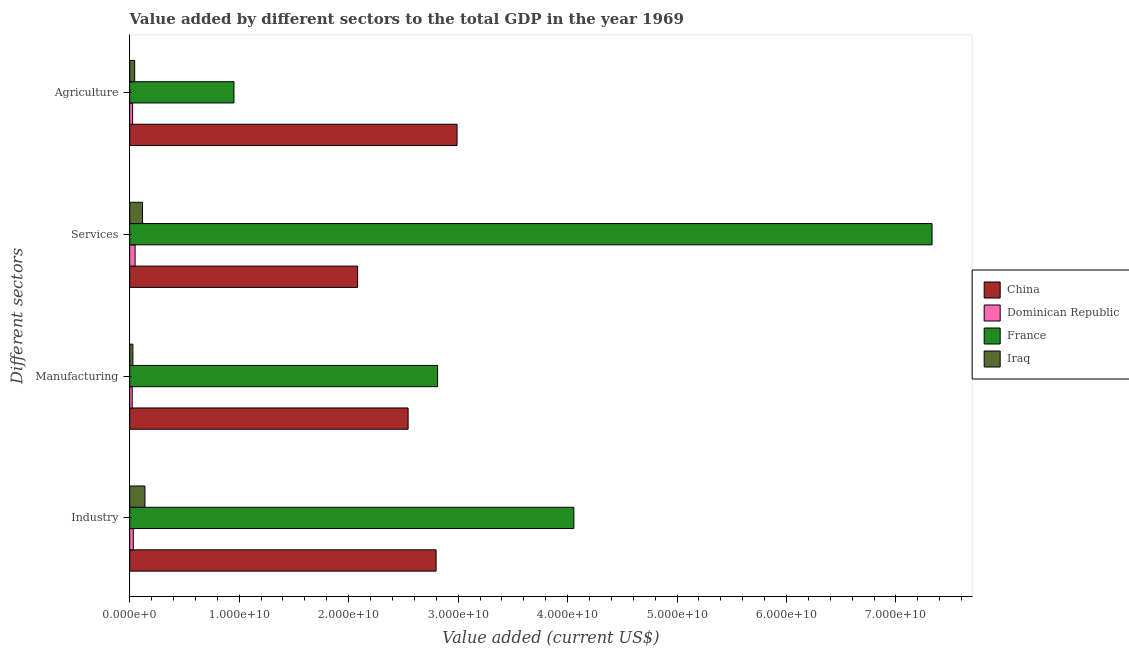How many groups of bars are there?
Offer a terse response. 4. Are the number of bars per tick equal to the number of legend labels?
Offer a terse response. Yes. How many bars are there on the 2nd tick from the top?
Your response must be concise. 4. How many bars are there on the 1st tick from the bottom?
Ensure brevity in your answer.  4. What is the label of the 4th group of bars from the top?
Offer a terse response. Industry. What is the value added by manufacturing sector in Dominican Republic?
Provide a short and direct response. 2.30e+08. Across all countries, what is the maximum value added by services sector?
Provide a short and direct response. 7.33e+1. Across all countries, what is the minimum value added by agricultural sector?
Offer a terse response. 2.62e+08. In which country was the value added by industrial sector minimum?
Your answer should be very brief. Dominican Republic. What is the total value added by agricultural sector in the graph?
Offer a very short reply. 4.01e+1. What is the difference between the value added by manufacturing sector in France and that in Iraq?
Provide a succinct answer. 2.78e+1. What is the difference between the value added by agricultural sector in China and the value added by manufacturing sector in Dominican Republic?
Your response must be concise. 2.97e+1. What is the average value added by agricultural sector per country?
Make the answer very short. 1.00e+1. What is the difference between the value added by manufacturing sector and value added by agricultural sector in Dominican Republic?
Your answer should be very brief. -3.24e+07. What is the ratio of the value added by manufacturing sector in Dominican Republic to that in France?
Ensure brevity in your answer.  0.01. Is the value added by industrial sector in Iraq less than that in France?
Give a very brief answer. Yes. What is the difference between the highest and the second highest value added by services sector?
Provide a short and direct response. 5.25e+1. What is the difference between the highest and the lowest value added by agricultural sector?
Offer a terse response. 2.96e+1. In how many countries, is the value added by services sector greater than the average value added by services sector taken over all countries?
Offer a very short reply. 1. Is the sum of the value added by services sector in Dominican Republic and France greater than the maximum value added by industrial sector across all countries?
Provide a short and direct response. Yes. How many countries are there in the graph?
Your answer should be very brief. 4. How many legend labels are there?
Your response must be concise. 4. What is the title of the graph?
Give a very brief answer. Value added by different sectors to the total GDP in the year 1969. Does "Andorra" appear as one of the legend labels in the graph?
Your response must be concise. No. What is the label or title of the X-axis?
Provide a succinct answer. Value added (current US$). What is the label or title of the Y-axis?
Your answer should be compact. Different sectors. What is the Value added (current US$) in China in Industry?
Give a very brief answer. 2.80e+1. What is the Value added (current US$) of Dominican Republic in Industry?
Keep it short and to the point. 3.27e+08. What is the Value added (current US$) of France in Industry?
Make the answer very short. 4.06e+1. What is the Value added (current US$) in Iraq in Industry?
Your answer should be compact. 1.39e+09. What is the Value added (current US$) of China in Manufacturing?
Provide a succinct answer. 2.54e+1. What is the Value added (current US$) of Dominican Republic in Manufacturing?
Your answer should be very brief. 2.30e+08. What is the Value added (current US$) in France in Manufacturing?
Make the answer very short. 2.81e+1. What is the Value added (current US$) of Iraq in Manufacturing?
Provide a short and direct response. 2.88e+08. What is the Value added (current US$) of China in Services?
Give a very brief answer. 2.08e+1. What is the Value added (current US$) in Dominican Republic in Services?
Your answer should be very brief. 4.90e+08. What is the Value added (current US$) of France in Services?
Offer a terse response. 7.33e+1. What is the Value added (current US$) of Iraq in Services?
Make the answer very short. 1.17e+09. What is the Value added (current US$) of China in Agriculture?
Provide a succinct answer. 2.99e+1. What is the Value added (current US$) in Dominican Republic in Agriculture?
Your response must be concise. 2.62e+08. What is the Value added (current US$) in France in Agriculture?
Your answer should be compact. 9.52e+09. What is the Value added (current US$) of Iraq in Agriculture?
Your answer should be very brief. 4.52e+08. Across all Different sectors, what is the maximum Value added (current US$) in China?
Your response must be concise. 2.99e+1. Across all Different sectors, what is the maximum Value added (current US$) of Dominican Republic?
Your response must be concise. 4.90e+08. Across all Different sectors, what is the maximum Value added (current US$) of France?
Keep it short and to the point. 7.33e+1. Across all Different sectors, what is the maximum Value added (current US$) in Iraq?
Offer a very short reply. 1.39e+09. Across all Different sectors, what is the minimum Value added (current US$) in China?
Your response must be concise. 2.08e+1. Across all Different sectors, what is the minimum Value added (current US$) of Dominican Republic?
Your response must be concise. 2.30e+08. Across all Different sectors, what is the minimum Value added (current US$) of France?
Offer a very short reply. 9.52e+09. Across all Different sectors, what is the minimum Value added (current US$) of Iraq?
Provide a short and direct response. 2.88e+08. What is the total Value added (current US$) in China in the graph?
Provide a short and direct response. 1.04e+11. What is the total Value added (current US$) of Dominican Republic in the graph?
Offer a terse response. 1.31e+09. What is the total Value added (current US$) in France in the graph?
Give a very brief answer. 1.52e+11. What is the total Value added (current US$) in Iraq in the graph?
Keep it short and to the point. 3.30e+09. What is the difference between the Value added (current US$) in China in Industry and that in Manufacturing?
Your response must be concise. 2.56e+09. What is the difference between the Value added (current US$) of Dominican Republic in Industry and that in Manufacturing?
Keep it short and to the point. 9.74e+07. What is the difference between the Value added (current US$) of France in Industry and that in Manufacturing?
Keep it short and to the point. 1.24e+1. What is the difference between the Value added (current US$) of Iraq in Industry and that in Manufacturing?
Ensure brevity in your answer.  1.10e+09. What is the difference between the Value added (current US$) of China in Industry and that in Services?
Provide a succinct answer. 7.17e+09. What is the difference between the Value added (current US$) of Dominican Republic in Industry and that in Services?
Your response must be concise. -1.63e+08. What is the difference between the Value added (current US$) of France in Industry and that in Services?
Provide a short and direct response. -3.27e+1. What is the difference between the Value added (current US$) of Iraq in Industry and that in Services?
Provide a short and direct response. 2.20e+08. What is the difference between the Value added (current US$) of China in Industry and that in Agriculture?
Your answer should be compact. -1.91e+09. What is the difference between the Value added (current US$) of Dominican Republic in Industry and that in Agriculture?
Offer a terse response. 6.50e+07. What is the difference between the Value added (current US$) of France in Industry and that in Agriculture?
Give a very brief answer. 3.11e+1. What is the difference between the Value added (current US$) of Iraq in Industry and that in Agriculture?
Your answer should be compact. 9.36e+08. What is the difference between the Value added (current US$) of China in Manufacturing and that in Services?
Your response must be concise. 4.61e+09. What is the difference between the Value added (current US$) in Dominican Republic in Manufacturing and that in Services?
Make the answer very short. -2.61e+08. What is the difference between the Value added (current US$) of France in Manufacturing and that in Services?
Offer a very short reply. -4.52e+1. What is the difference between the Value added (current US$) of Iraq in Manufacturing and that in Services?
Give a very brief answer. -8.80e+08. What is the difference between the Value added (current US$) of China in Manufacturing and that in Agriculture?
Make the answer very short. -4.47e+09. What is the difference between the Value added (current US$) in Dominican Republic in Manufacturing and that in Agriculture?
Your answer should be very brief. -3.24e+07. What is the difference between the Value added (current US$) in France in Manufacturing and that in Agriculture?
Your answer should be very brief. 1.86e+1. What is the difference between the Value added (current US$) of Iraq in Manufacturing and that in Agriculture?
Provide a succinct answer. -1.64e+08. What is the difference between the Value added (current US$) of China in Services and that in Agriculture?
Provide a succinct answer. -9.08e+09. What is the difference between the Value added (current US$) of Dominican Republic in Services and that in Agriculture?
Keep it short and to the point. 2.28e+08. What is the difference between the Value added (current US$) of France in Services and that in Agriculture?
Your answer should be compact. 6.38e+1. What is the difference between the Value added (current US$) of Iraq in Services and that in Agriculture?
Give a very brief answer. 7.16e+08. What is the difference between the Value added (current US$) of China in Industry and the Value added (current US$) of Dominican Republic in Manufacturing?
Offer a very short reply. 2.78e+1. What is the difference between the Value added (current US$) of China in Industry and the Value added (current US$) of France in Manufacturing?
Your response must be concise. -1.35e+08. What is the difference between the Value added (current US$) of China in Industry and the Value added (current US$) of Iraq in Manufacturing?
Your answer should be very brief. 2.77e+1. What is the difference between the Value added (current US$) of Dominican Republic in Industry and the Value added (current US$) of France in Manufacturing?
Keep it short and to the point. -2.78e+1. What is the difference between the Value added (current US$) in Dominican Republic in Industry and the Value added (current US$) in Iraq in Manufacturing?
Ensure brevity in your answer.  3.87e+07. What is the difference between the Value added (current US$) of France in Industry and the Value added (current US$) of Iraq in Manufacturing?
Ensure brevity in your answer.  4.03e+1. What is the difference between the Value added (current US$) of China in Industry and the Value added (current US$) of Dominican Republic in Services?
Provide a short and direct response. 2.75e+1. What is the difference between the Value added (current US$) in China in Industry and the Value added (current US$) in France in Services?
Your response must be concise. -4.53e+1. What is the difference between the Value added (current US$) in China in Industry and the Value added (current US$) in Iraq in Services?
Your response must be concise. 2.68e+1. What is the difference between the Value added (current US$) in Dominican Republic in Industry and the Value added (current US$) in France in Services?
Your response must be concise. -7.30e+1. What is the difference between the Value added (current US$) in Dominican Republic in Industry and the Value added (current US$) in Iraq in Services?
Provide a succinct answer. -8.41e+08. What is the difference between the Value added (current US$) of France in Industry and the Value added (current US$) of Iraq in Services?
Make the answer very short. 3.94e+1. What is the difference between the Value added (current US$) of China in Industry and the Value added (current US$) of Dominican Republic in Agriculture?
Offer a very short reply. 2.77e+1. What is the difference between the Value added (current US$) in China in Industry and the Value added (current US$) in France in Agriculture?
Provide a short and direct response. 1.85e+1. What is the difference between the Value added (current US$) in China in Industry and the Value added (current US$) in Iraq in Agriculture?
Ensure brevity in your answer.  2.75e+1. What is the difference between the Value added (current US$) in Dominican Republic in Industry and the Value added (current US$) in France in Agriculture?
Offer a very short reply. -9.20e+09. What is the difference between the Value added (current US$) in Dominican Republic in Industry and the Value added (current US$) in Iraq in Agriculture?
Offer a very short reply. -1.25e+08. What is the difference between the Value added (current US$) in France in Industry and the Value added (current US$) in Iraq in Agriculture?
Provide a succinct answer. 4.01e+1. What is the difference between the Value added (current US$) in China in Manufacturing and the Value added (current US$) in Dominican Republic in Services?
Your answer should be compact. 2.49e+1. What is the difference between the Value added (current US$) in China in Manufacturing and the Value added (current US$) in France in Services?
Ensure brevity in your answer.  -4.79e+1. What is the difference between the Value added (current US$) in China in Manufacturing and the Value added (current US$) in Iraq in Services?
Your response must be concise. 2.43e+1. What is the difference between the Value added (current US$) of Dominican Republic in Manufacturing and the Value added (current US$) of France in Services?
Ensure brevity in your answer.  -7.31e+1. What is the difference between the Value added (current US$) in Dominican Republic in Manufacturing and the Value added (current US$) in Iraq in Services?
Your answer should be very brief. -9.39e+08. What is the difference between the Value added (current US$) of France in Manufacturing and the Value added (current US$) of Iraq in Services?
Give a very brief answer. 2.70e+1. What is the difference between the Value added (current US$) of China in Manufacturing and the Value added (current US$) of Dominican Republic in Agriculture?
Your answer should be compact. 2.52e+1. What is the difference between the Value added (current US$) in China in Manufacturing and the Value added (current US$) in France in Agriculture?
Keep it short and to the point. 1.59e+1. What is the difference between the Value added (current US$) in China in Manufacturing and the Value added (current US$) in Iraq in Agriculture?
Your answer should be compact. 2.50e+1. What is the difference between the Value added (current US$) of Dominican Republic in Manufacturing and the Value added (current US$) of France in Agriculture?
Your answer should be compact. -9.29e+09. What is the difference between the Value added (current US$) of Dominican Republic in Manufacturing and the Value added (current US$) of Iraq in Agriculture?
Give a very brief answer. -2.22e+08. What is the difference between the Value added (current US$) of France in Manufacturing and the Value added (current US$) of Iraq in Agriculture?
Provide a succinct answer. 2.77e+1. What is the difference between the Value added (current US$) of China in Services and the Value added (current US$) of Dominican Republic in Agriculture?
Provide a short and direct response. 2.06e+1. What is the difference between the Value added (current US$) of China in Services and the Value added (current US$) of France in Agriculture?
Ensure brevity in your answer.  1.13e+1. What is the difference between the Value added (current US$) of China in Services and the Value added (current US$) of Iraq in Agriculture?
Your answer should be compact. 2.04e+1. What is the difference between the Value added (current US$) of Dominican Republic in Services and the Value added (current US$) of France in Agriculture?
Your response must be concise. -9.03e+09. What is the difference between the Value added (current US$) of Dominican Republic in Services and the Value added (current US$) of Iraq in Agriculture?
Your response must be concise. 3.83e+07. What is the difference between the Value added (current US$) of France in Services and the Value added (current US$) of Iraq in Agriculture?
Make the answer very short. 7.28e+1. What is the average Value added (current US$) in China per Different sectors?
Give a very brief answer. 2.60e+1. What is the average Value added (current US$) in Dominican Republic per Different sectors?
Offer a terse response. 3.27e+08. What is the average Value added (current US$) in France per Different sectors?
Keep it short and to the point. 3.79e+1. What is the average Value added (current US$) in Iraq per Different sectors?
Ensure brevity in your answer.  8.24e+08. What is the difference between the Value added (current US$) in China and Value added (current US$) in Dominican Republic in Industry?
Ensure brevity in your answer.  2.77e+1. What is the difference between the Value added (current US$) of China and Value added (current US$) of France in Industry?
Your answer should be very brief. -1.26e+1. What is the difference between the Value added (current US$) in China and Value added (current US$) in Iraq in Industry?
Offer a terse response. 2.66e+1. What is the difference between the Value added (current US$) in Dominican Republic and Value added (current US$) in France in Industry?
Give a very brief answer. -4.02e+1. What is the difference between the Value added (current US$) of Dominican Republic and Value added (current US$) of Iraq in Industry?
Offer a terse response. -1.06e+09. What is the difference between the Value added (current US$) in France and Value added (current US$) in Iraq in Industry?
Offer a terse response. 3.92e+1. What is the difference between the Value added (current US$) in China and Value added (current US$) in Dominican Republic in Manufacturing?
Provide a short and direct response. 2.52e+1. What is the difference between the Value added (current US$) of China and Value added (current US$) of France in Manufacturing?
Make the answer very short. -2.69e+09. What is the difference between the Value added (current US$) in China and Value added (current US$) in Iraq in Manufacturing?
Provide a succinct answer. 2.51e+1. What is the difference between the Value added (current US$) in Dominican Republic and Value added (current US$) in France in Manufacturing?
Provide a succinct answer. -2.79e+1. What is the difference between the Value added (current US$) of Dominican Republic and Value added (current US$) of Iraq in Manufacturing?
Your response must be concise. -5.87e+07. What is the difference between the Value added (current US$) in France and Value added (current US$) in Iraq in Manufacturing?
Your answer should be very brief. 2.78e+1. What is the difference between the Value added (current US$) in China and Value added (current US$) in Dominican Republic in Services?
Give a very brief answer. 2.03e+1. What is the difference between the Value added (current US$) in China and Value added (current US$) in France in Services?
Make the answer very short. -5.25e+1. What is the difference between the Value added (current US$) of China and Value added (current US$) of Iraq in Services?
Ensure brevity in your answer.  1.97e+1. What is the difference between the Value added (current US$) in Dominican Republic and Value added (current US$) in France in Services?
Offer a terse response. -7.28e+1. What is the difference between the Value added (current US$) in Dominican Republic and Value added (current US$) in Iraq in Services?
Your response must be concise. -6.78e+08. What is the difference between the Value added (current US$) in France and Value added (current US$) in Iraq in Services?
Provide a short and direct response. 7.21e+1. What is the difference between the Value added (current US$) in China and Value added (current US$) in Dominican Republic in Agriculture?
Your answer should be compact. 2.96e+1. What is the difference between the Value added (current US$) in China and Value added (current US$) in France in Agriculture?
Your response must be concise. 2.04e+1. What is the difference between the Value added (current US$) of China and Value added (current US$) of Iraq in Agriculture?
Offer a very short reply. 2.95e+1. What is the difference between the Value added (current US$) of Dominican Republic and Value added (current US$) of France in Agriculture?
Ensure brevity in your answer.  -9.26e+09. What is the difference between the Value added (current US$) in Dominican Republic and Value added (current US$) in Iraq in Agriculture?
Offer a very short reply. -1.90e+08. What is the difference between the Value added (current US$) of France and Value added (current US$) of Iraq in Agriculture?
Make the answer very short. 9.07e+09. What is the ratio of the Value added (current US$) in China in Industry to that in Manufacturing?
Your answer should be very brief. 1.1. What is the ratio of the Value added (current US$) in Dominican Republic in Industry to that in Manufacturing?
Ensure brevity in your answer.  1.42. What is the ratio of the Value added (current US$) in France in Industry to that in Manufacturing?
Your answer should be compact. 1.44. What is the ratio of the Value added (current US$) of Iraq in Industry to that in Manufacturing?
Provide a succinct answer. 4.81. What is the ratio of the Value added (current US$) of China in Industry to that in Services?
Provide a succinct answer. 1.34. What is the ratio of the Value added (current US$) in Dominican Republic in Industry to that in Services?
Provide a short and direct response. 0.67. What is the ratio of the Value added (current US$) of France in Industry to that in Services?
Give a very brief answer. 0.55. What is the ratio of the Value added (current US$) of Iraq in Industry to that in Services?
Make the answer very short. 1.19. What is the ratio of the Value added (current US$) in China in Industry to that in Agriculture?
Offer a terse response. 0.94. What is the ratio of the Value added (current US$) of Dominican Republic in Industry to that in Agriculture?
Ensure brevity in your answer.  1.25. What is the ratio of the Value added (current US$) in France in Industry to that in Agriculture?
Your answer should be compact. 4.26. What is the ratio of the Value added (current US$) of Iraq in Industry to that in Agriculture?
Ensure brevity in your answer.  3.07. What is the ratio of the Value added (current US$) in China in Manufacturing to that in Services?
Offer a terse response. 1.22. What is the ratio of the Value added (current US$) of Dominican Republic in Manufacturing to that in Services?
Your answer should be compact. 0.47. What is the ratio of the Value added (current US$) in France in Manufacturing to that in Services?
Provide a succinct answer. 0.38. What is the ratio of the Value added (current US$) in Iraq in Manufacturing to that in Services?
Provide a succinct answer. 0.25. What is the ratio of the Value added (current US$) of China in Manufacturing to that in Agriculture?
Provide a succinct answer. 0.85. What is the ratio of the Value added (current US$) of Dominican Republic in Manufacturing to that in Agriculture?
Your response must be concise. 0.88. What is the ratio of the Value added (current US$) in France in Manufacturing to that in Agriculture?
Keep it short and to the point. 2.95. What is the ratio of the Value added (current US$) in Iraq in Manufacturing to that in Agriculture?
Your answer should be compact. 0.64. What is the ratio of the Value added (current US$) in China in Services to that in Agriculture?
Offer a very short reply. 0.7. What is the ratio of the Value added (current US$) in Dominican Republic in Services to that in Agriculture?
Make the answer very short. 1.87. What is the ratio of the Value added (current US$) of France in Services to that in Agriculture?
Give a very brief answer. 7.7. What is the ratio of the Value added (current US$) in Iraq in Services to that in Agriculture?
Provide a short and direct response. 2.58. What is the difference between the highest and the second highest Value added (current US$) of China?
Your response must be concise. 1.91e+09. What is the difference between the highest and the second highest Value added (current US$) of Dominican Republic?
Ensure brevity in your answer.  1.63e+08. What is the difference between the highest and the second highest Value added (current US$) in France?
Your answer should be compact. 3.27e+1. What is the difference between the highest and the second highest Value added (current US$) of Iraq?
Your answer should be compact. 2.20e+08. What is the difference between the highest and the lowest Value added (current US$) in China?
Provide a short and direct response. 9.08e+09. What is the difference between the highest and the lowest Value added (current US$) in Dominican Republic?
Offer a very short reply. 2.61e+08. What is the difference between the highest and the lowest Value added (current US$) in France?
Give a very brief answer. 6.38e+1. What is the difference between the highest and the lowest Value added (current US$) of Iraq?
Provide a succinct answer. 1.10e+09. 